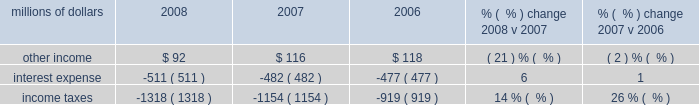Compared to 2007 .
We reduced personal injury expense by $ 80 million in 2007 as a result of fewer than expected claims and lower than expected average settlement costs .
In 2008 , we reduced personal injury expense and asbestos-related costs $ 82 million based on the results of updated personal injury actuarial studies and a reassessment of our potential liability for resolution of current and future asbestos claims .
In addition , environmental and toxic tort expenses were $ 7 million lower in 2008 compared to 2007 .
Other costs were lower in 2007 compared to 2006 driven primarily by a reduction in personal injury expense .
Actuarial studies completed during 2007 resulted in a reduction in personal injury expense of $ 80 million , which was partially offset by an adverse development with respect to one claim .
Settlement of insurance claims in 2007 related to hurricane rita , and higher equity income also drove expenses lower in 2007 versus 2006 .
Conversely , the year-over-year comparison was affected by the settlement of insurance claims totaling $ 23 million in 2006 related to the january 2005 west coast storm and a $ 9 million gain in 2006 from the sale of two company-owned airplanes .
Non-operating items millions of dollars 2008 2007 2006 % (  % ) change 2008 v 2007 % (  % ) change 2007 v 2006 .
Other income 2013 other income decreased in 2008 compared to 2007 due to lower gains from real estate sales and decreased returns on cash investments reflecting lower interest rates .
Higher rental and licensing income and lower interest expense on our sale of receivables program partially offset the decreases .
Lower net gains from non-operating asset sales ( primarily real estate ) drove the reduction in other income in 2007 .
Recognition of rental income in 2006 from the settlement of a rent dispute also contributed to the year-over-year decrease in other income .
Cash investment returns increased $ 21 million due to larger cash balances and higher interest rates .
Interest expense 2013 interest expense increased in 2008 versus 2007 due to a higher weighted-average debt level of $ 8.3 billion , compared to $ 7.3 billion in 2007 .
A lower effective interest rate of 6.1% ( 6.1 % ) in 2008 , compared to 6.6% ( 6.6 % ) in 2007 , partially offset the effects of the higher weighted-average debt level .
An increase in the weighted-average debt levels to $ 7.3 billion from $ 7.1 billion in 2006 generated higher interest expense in 2007 .
A lower effective interest rate of 6.6% ( 6.6 % ) in 2007 , compared to 6.7% ( 6.7 % ) in 2006 , partially offset the effects of the higher debt level .
Income taxes 2013 income taxes were higher in 2008 compared to 2007 , driven by higher pre-tax income .
Our effective tax rates were 36.1% ( 36.1 % ) and 38.4% ( 38.4 % ) in 2008 and 2007 , respectively .
The lower effective tax rate in 2008 resulted from several reductions in tax expense related to federal audits and state tax law changes .
In addition , the effective tax rate in 2007 was increased by illinois legislation that increased deferred tax expense in the third quarter of 2007 .
Income taxes were $ 235 million higher in 2007 compared to 2006 , due primarily to higher pre-tax income and the effect of new tax legislation in the state of illinois that changed how we determine the amount of our income subject to illinois tax .
The illinois legislation increased our deferred tax expense by $ 27 million in 2007 .
Our effective tax rates were 38.4% ( 38.4 % ) and 36.4% ( 36.4 % ) in 2007 and 2006 , respectively. .
In 2008 what was the ratio of the reduction of the personal injury expense and asbestos-related costs to the environmental and toxic tort expenses? 
Computations: (82 / 7)
Answer: 11.71429. 